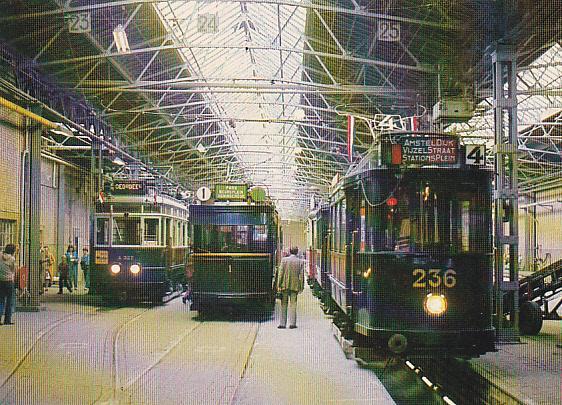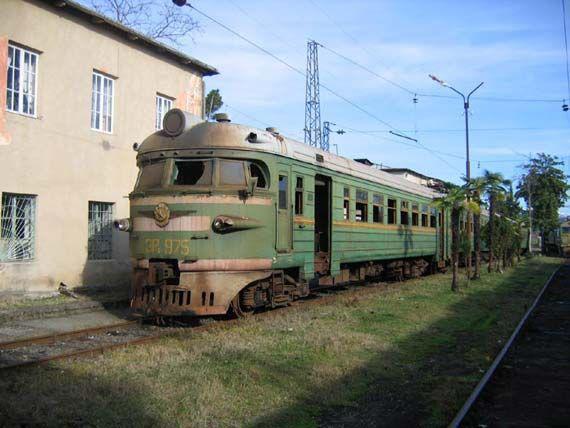The first image is the image on the left, the second image is the image on the right. Given the left and right images, does the statement "There are two trains in the pair of images, both traveling slightly towards the right." hold true? Answer yes or no. No. The first image is the image on the left, the second image is the image on the right. Given the left and right images, does the statement "Each image shows one train, which is heading rightward." hold true? Answer yes or no. No. 